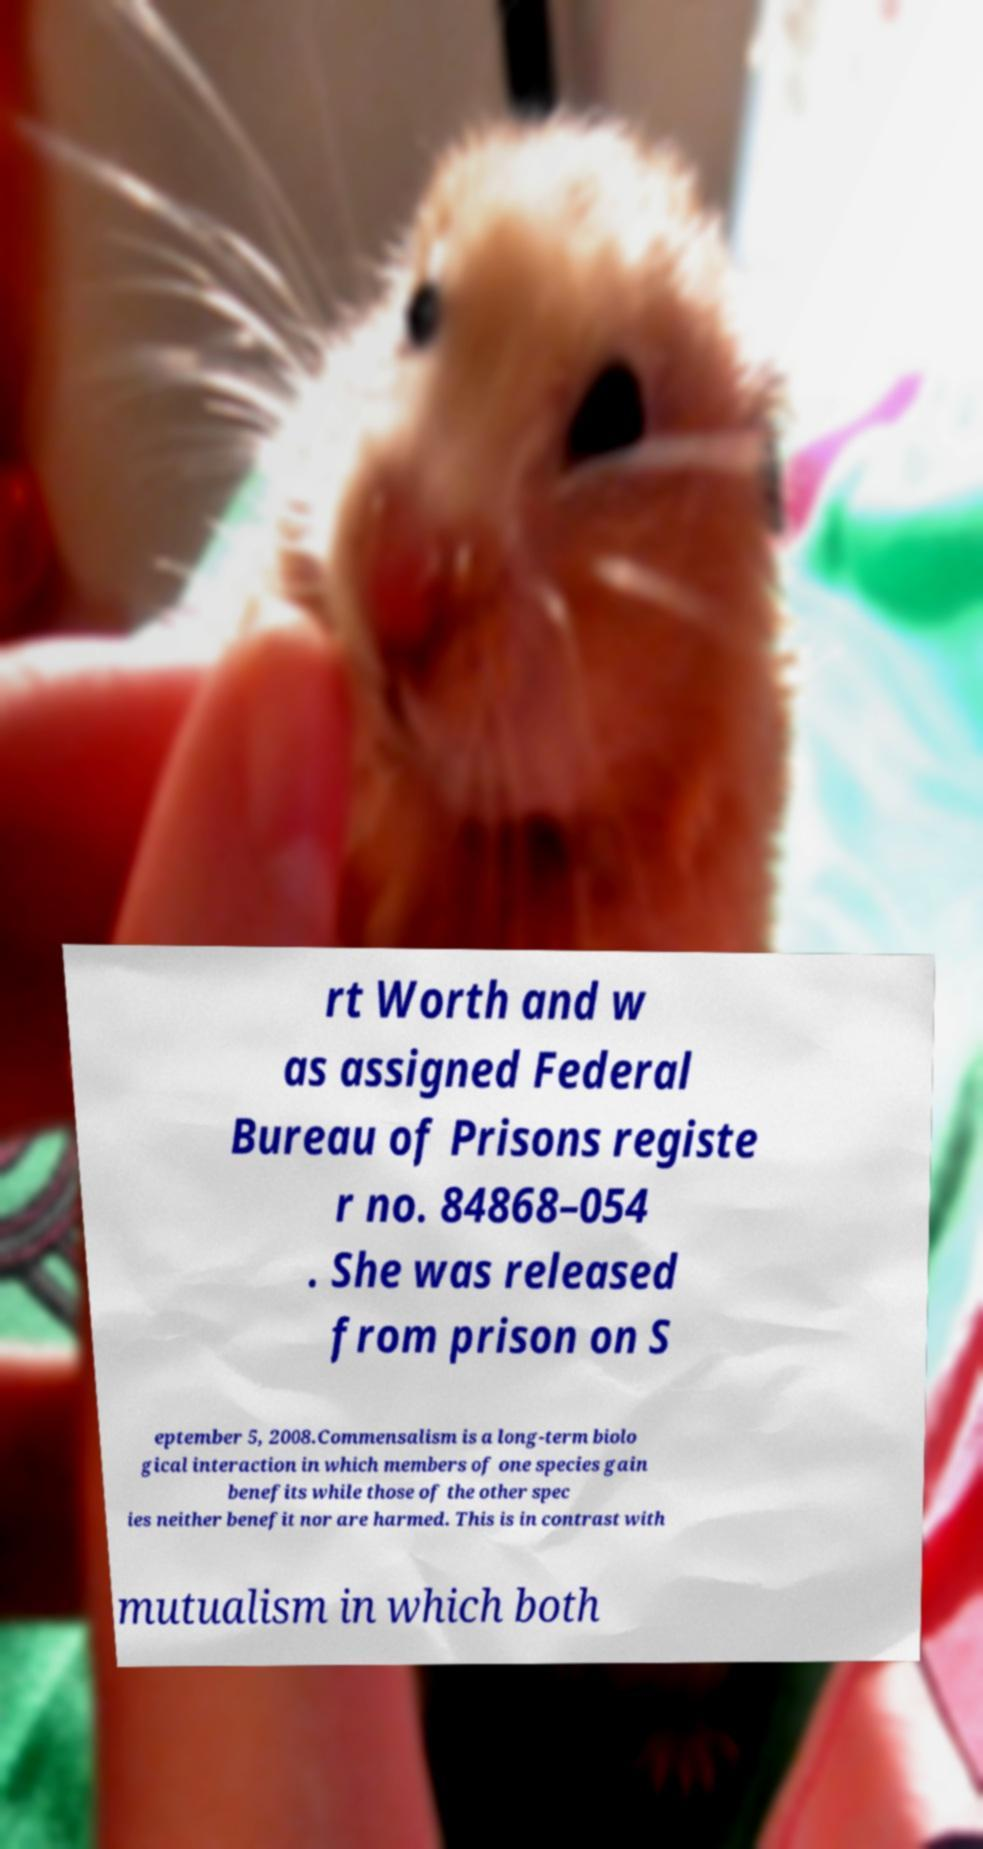Can you read and provide the text displayed in the image?This photo seems to have some interesting text. Can you extract and type it out for me? rt Worth and w as assigned Federal Bureau of Prisons registe r no. 84868–054 . She was released from prison on S eptember 5, 2008.Commensalism is a long-term biolo gical interaction in which members of one species gain benefits while those of the other spec ies neither benefit nor are harmed. This is in contrast with mutualism in which both 